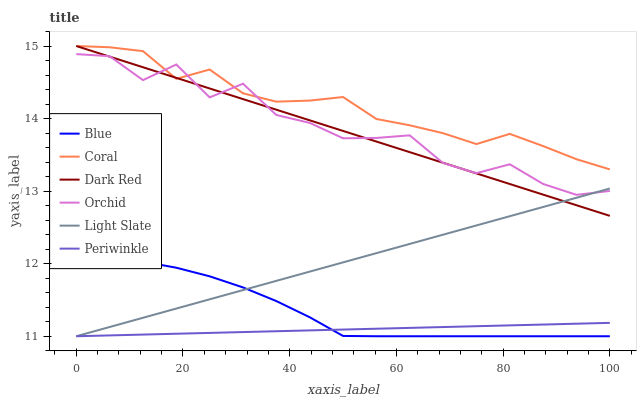Does Periwinkle have the minimum area under the curve?
Answer yes or no. Yes. Does Coral have the maximum area under the curve?
Answer yes or no. Yes. Does Light Slate have the minimum area under the curve?
Answer yes or no. No. Does Light Slate have the maximum area under the curve?
Answer yes or no. No. Is Periwinkle the smoothest?
Answer yes or no. Yes. Is Orchid the roughest?
Answer yes or no. Yes. Is Light Slate the smoothest?
Answer yes or no. No. Is Light Slate the roughest?
Answer yes or no. No. Does Dark Red have the lowest value?
Answer yes or no. No. Does Coral have the highest value?
Answer yes or no. Yes. Does Light Slate have the highest value?
Answer yes or no. No. Is Periwinkle less than Coral?
Answer yes or no. Yes. Is Orchid greater than Periwinkle?
Answer yes or no. Yes. Does Dark Red intersect Orchid?
Answer yes or no. Yes. Is Dark Red less than Orchid?
Answer yes or no. No. Is Dark Red greater than Orchid?
Answer yes or no. No. Does Periwinkle intersect Coral?
Answer yes or no. No. 